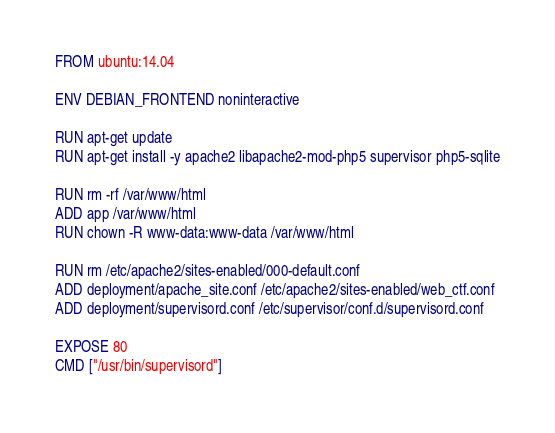Convert code to text. <code><loc_0><loc_0><loc_500><loc_500><_Dockerfile_>FROM ubuntu:14.04

ENV DEBIAN_FRONTEND noninteractive

RUN apt-get update
RUN apt-get install -y apache2 libapache2-mod-php5 supervisor php5-sqlite

RUN rm -rf /var/www/html
ADD app /var/www/html
RUN chown -R www-data:www-data /var/www/html

RUN rm /etc/apache2/sites-enabled/000-default.conf
ADD deployment/apache_site.conf /etc/apache2/sites-enabled/web_ctf.conf
ADD deployment/supervisord.conf /etc/supervisor/conf.d/supervisord.conf

EXPOSE 80
CMD ["/usr/bin/supervisord"]
</code> 